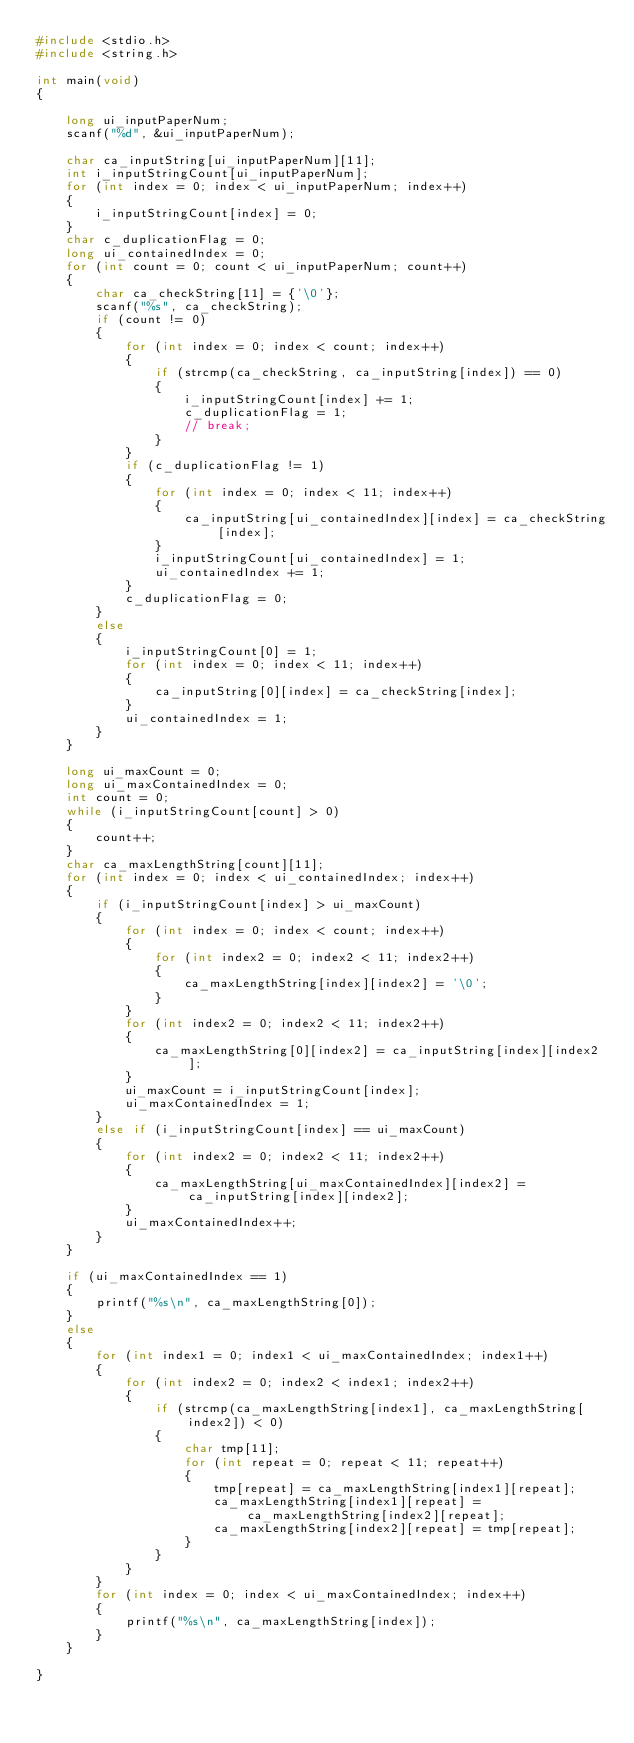Convert code to text. <code><loc_0><loc_0><loc_500><loc_500><_C_>#include <stdio.h>
#include <string.h>

int main(void)
{

    long ui_inputPaperNum;
    scanf("%d", &ui_inputPaperNum);

    char ca_inputString[ui_inputPaperNum][11];
    int i_inputStringCount[ui_inputPaperNum];
    for (int index = 0; index < ui_inputPaperNum; index++)
    {
        i_inputStringCount[index] = 0;
    }
    char c_duplicationFlag = 0;
    long ui_containedIndex = 0;
    for (int count = 0; count < ui_inputPaperNum; count++)
    {
        char ca_checkString[11] = {'\0'};
        scanf("%s", ca_checkString);
        if (count != 0)
        {
            for (int index = 0; index < count; index++)
            {
                if (strcmp(ca_checkString, ca_inputString[index]) == 0)
                {
                    i_inputStringCount[index] += 1;
                    c_duplicationFlag = 1;
                    // break;
                }
            }
            if (c_duplicationFlag != 1)
            {
                for (int index = 0; index < 11; index++)
                {
                    ca_inputString[ui_containedIndex][index] = ca_checkString[index];
                }
                i_inputStringCount[ui_containedIndex] = 1;
                ui_containedIndex += 1;
            }
            c_duplicationFlag = 0;
        }
        else
        {
            i_inputStringCount[0] = 1;
            for (int index = 0; index < 11; index++)
            {
                ca_inputString[0][index] = ca_checkString[index];
            }
            ui_containedIndex = 1;
        }
    }

    long ui_maxCount = 0;
    long ui_maxContainedIndex = 0;
    int count = 0;
    while (i_inputStringCount[count] > 0)
    {
        count++;
    }
    char ca_maxLengthString[count][11];
    for (int index = 0; index < ui_containedIndex; index++)
    {
        if (i_inputStringCount[index] > ui_maxCount)
        {
            for (int index = 0; index < count; index++)
            {
                for (int index2 = 0; index2 < 11; index2++)
                {
                    ca_maxLengthString[index][index2] = '\0';
                }
            }
            for (int index2 = 0; index2 < 11; index2++)
            {
                ca_maxLengthString[0][index2] = ca_inputString[index][index2];
            }
            ui_maxCount = i_inputStringCount[index];
            ui_maxContainedIndex = 1;
        }
        else if (i_inputStringCount[index] == ui_maxCount)
        {
            for (int index2 = 0; index2 < 11; index2++)
            {
                ca_maxLengthString[ui_maxContainedIndex][index2] = ca_inputString[index][index2];
            }
            ui_maxContainedIndex++;
        }
    }

    if (ui_maxContainedIndex == 1)
    {
        printf("%s\n", ca_maxLengthString[0]);
    }
    else
    {
        for (int index1 = 0; index1 < ui_maxContainedIndex; index1++)
        {
            for (int index2 = 0; index2 < index1; index2++)
            {
                if (strcmp(ca_maxLengthString[index1], ca_maxLengthString[index2]) < 0)
                {
                    char tmp[11];
                    for (int repeat = 0; repeat < 11; repeat++)
                    {
                        tmp[repeat] = ca_maxLengthString[index1][repeat];
                        ca_maxLengthString[index1][repeat] = ca_maxLengthString[index2][repeat];
                        ca_maxLengthString[index2][repeat] = tmp[repeat];
                    }
                }
            }
        }
        for (int index = 0; index < ui_maxContainedIndex; index++)
        {
            printf("%s\n", ca_maxLengthString[index]);
        }
    }
    
}</code> 